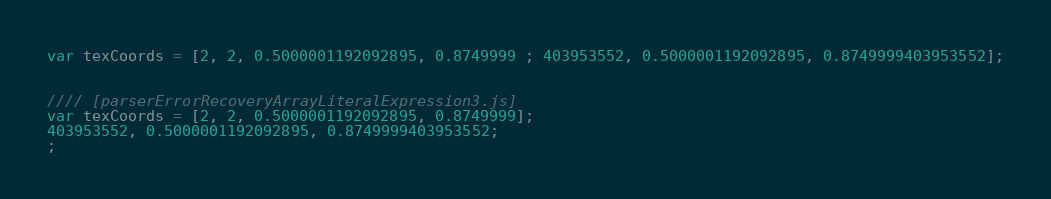<code> <loc_0><loc_0><loc_500><loc_500><_JavaScript_>var texCoords = [2, 2, 0.5000001192092895, 0.8749999 ; 403953552, 0.5000001192092895, 0.8749999403953552];


//// [parserErrorRecoveryArrayLiteralExpression3.js]
var texCoords = [2, 2, 0.5000001192092895, 0.8749999];
403953552, 0.5000001192092895, 0.8749999403953552;
;
</code> 